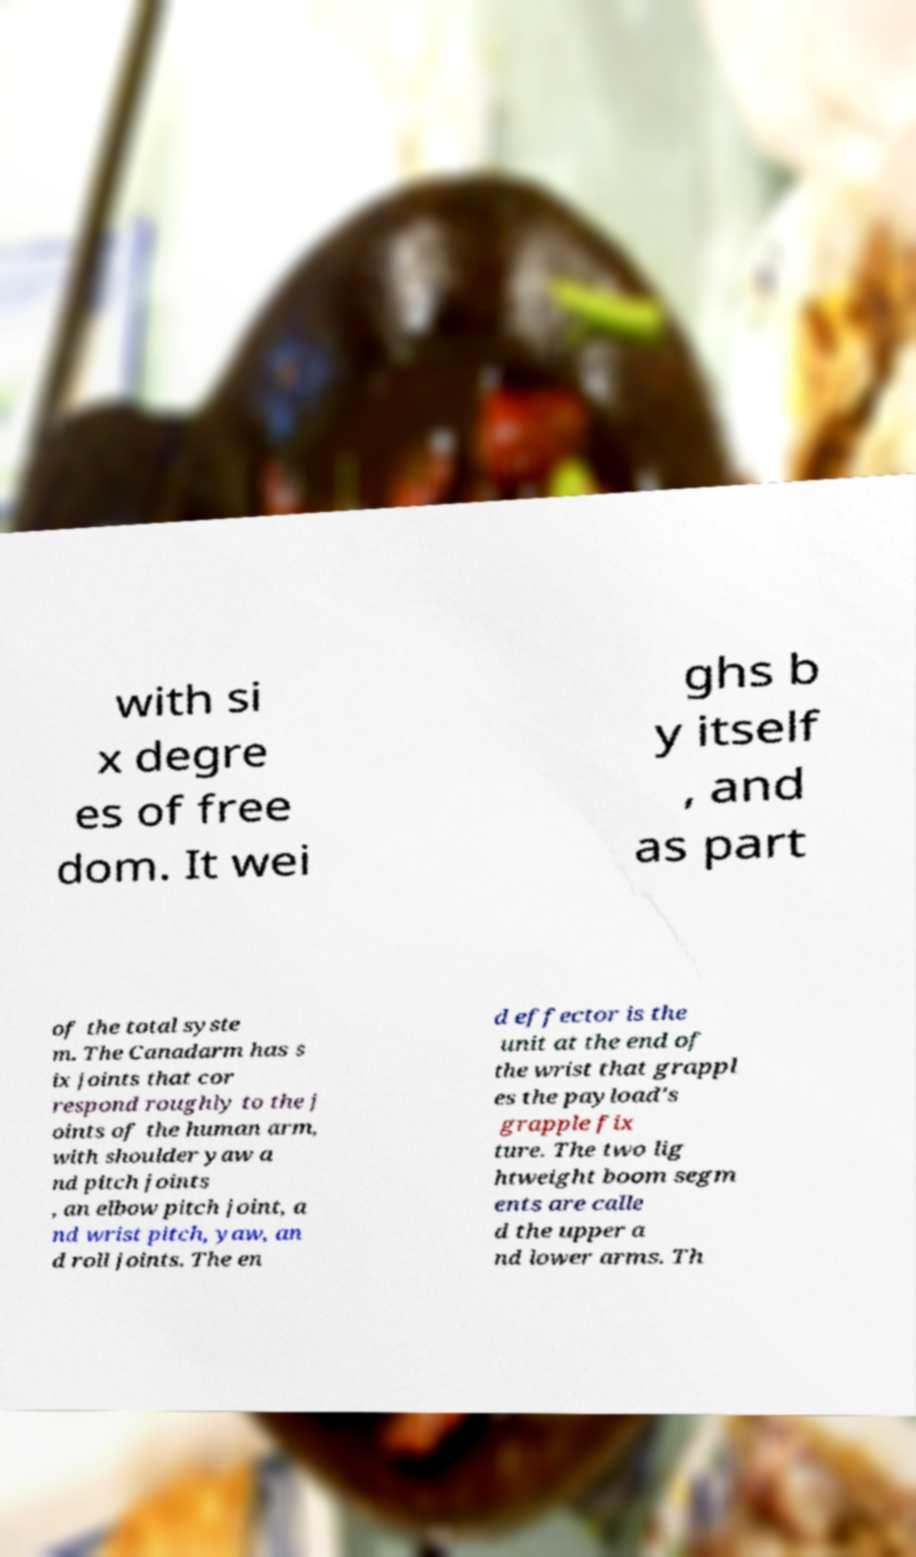What messages or text are displayed in this image? I need them in a readable, typed format. with si x degre es of free dom. It wei ghs b y itself , and as part of the total syste m. The Canadarm has s ix joints that cor respond roughly to the j oints of the human arm, with shoulder yaw a nd pitch joints , an elbow pitch joint, a nd wrist pitch, yaw, an d roll joints. The en d effector is the unit at the end of the wrist that grappl es the payload's grapple fix ture. The two lig htweight boom segm ents are calle d the upper a nd lower arms. Th 